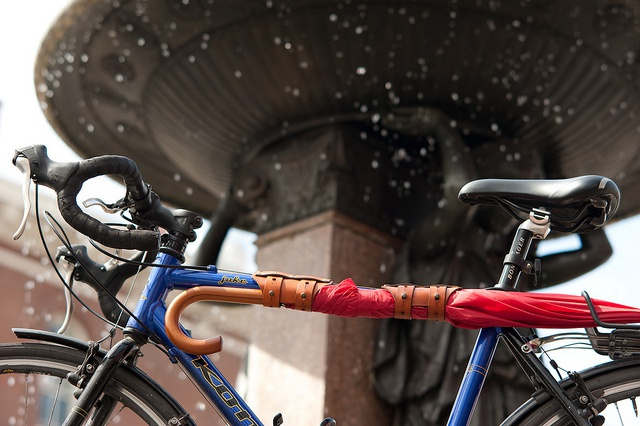Describe the objects in this image and their specific colors. I can see bicycle in white, black, maroon, and gray tones and umbrella in white, maroon, brown, and salmon tones in this image. 